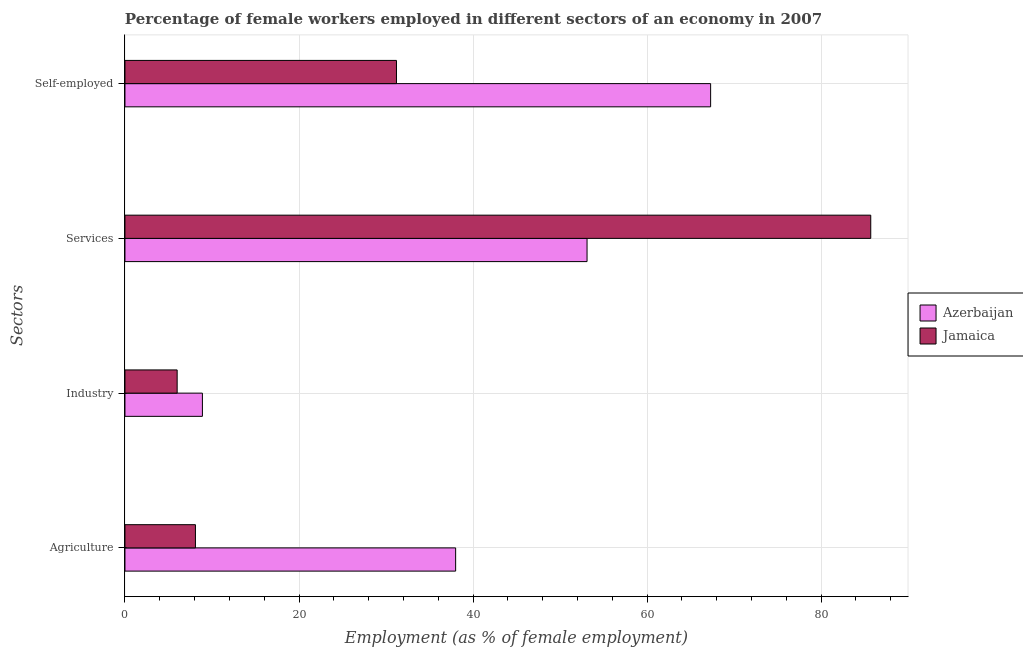How many groups of bars are there?
Make the answer very short. 4. Are the number of bars per tick equal to the number of legend labels?
Offer a terse response. Yes. Are the number of bars on each tick of the Y-axis equal?
Your answer should be very brief. Yes. How many bars are there on the 3rd tick from the top?
Your answer should be very brief. 2. How many bars are there on the 1st tick from the bottom?
Provide a short and direct response. 2. What is the label of the 2nd group of bars from the top?
Provide a succinct answer. Services. What is the percentage of female workers in industry in Azerbaijan?
Provide a short and direct response. 8.9. Across all countries, what is the maximum percentage of self employed female workers?
Offer a terse response. 67.3. Across all countries, what is the minimum percentage of self employed female workers?
Ensure brevity in your answer.  31.2. In which country was the percentage of self employed female workers maximum?
Ensure brevity in your answer.  Azerbaijan. In which country was the percentage of female workers in industry minimum?
Your answer should be very brief. Jamaica. What is the total percentage of female workers in services in the graph?
Give a very brief answer. 138.8. What is the difference between the percentage of female workers in industry in Azerbaijan and that in Jamaica?
Your response must be concise. 2.9. What is the difference between the percentage of self employed female workers in Azerbaijan and the percentage of female workers in services in Jamaica?
Your answer should be very brief. -18.4. What is the average percentage of female workers in services per country?
Offer a very short reply. 69.4. What is the difference between the percentage of female workers in agriculture and percentage of self employed female workers in Jamaica?
Your response must be concise. -23.1. What is the ratio of the percentage of female workers in services in Jamaica to that in Azerbaijan?
Provide a succinct answer. 1.61. What is the difference between the highest and the second highest percentage of female workers in services?
Provide a short and direct response. 32.6. What is the difference between the highest and the lowest percentage of female workers in services?
Your answer should be compact. 32.6. In how many countries, is the percentage of female workers in services greater than the average percentage of female workers in services taken over all countries?
Keep it short and to the point. 1. What does the 1st bar from the top in Agriculture represents?
Ensure brevity in your answer.  Jamaica. What does the 2nd bar from the bottom in Self-employed represents?
Offer a very short reply. Jamaica. Is it the case that in every country, the sum of the percentage of female workers in agriculture and percentage of female workers in industry is greater than the percentage of female workers in services?
Your answer should be compact. No. How many bars are there?
Make the answer very short. 8. Are all the bars in the graph horizontal?
Make the answer very short. Yes. What is the difference between two consecutive major ticks on the X-axis?
Make the answer very short. 20. Are the values on the major ticks of X-axis written in scientific E-notation?
Give a very brief answer. No. Does the graph contain any zero values?
Your answer should be very brief. No. Where does the legend appear in the graph?
Provide a short and direct response. Center right. What is the title of the graph?
Provide a succinct answer. Percentage of female workers employed in different sectors of an economy in 2007. What is the label or title of the X-axis?
Provide a succinct answer. Employment (as % of female employment). What is the label or title of the Y-axis?
Ensure brevity in your answer.  Sectors. What is the Employment (as % of female employment) of Azerbaijan in Agriculture?
Make the answer very short. 38. What is the Employment (as % of female employment) of Jamaica in Agriculture?
Give a very brief answer. 8.1. What is the Employment (as % of female employment) in Azerbaijan in Industry?
Your answer should be very brief. 8.9. What is the Employment (as % of female employment) in Azerbaijan in Services?
Offer a terse response. 53.1. What is the Employment (as % of female employment) of Jamaica in Services?
Your answer should be very brief. 85.7. What is the Employment (as % of female employment) in Azerbaijan in Self-employed?
Keep it short and to the point. 67.3. What is the Employment (as % of female employment) of Jamaica in Self-employed?
Provide a succinct answer. 31.2. Across all Sectors, what is the maximum Employment (as % of female employment) of Azerbaijan?
Your answer should be compact. 67.3. Across all Sectors, what is the maximum Employment (as % of female employment) in Jamaica?
Make the answer very short. 85.7. Across all Sectors, what is the minimum Employment (as % of female employment) in Azerbaijan?
Offer a terse response. 8.9. Across all Sectors, what is the minimum Employment (as % of female employment) of Jamaica?
Keep it short and to the point. 6. What is the total Employment (as % of female employment) of Azerbaijan in the graph?
Provide a succinct answer. 167.3. What is the total Employment (as % of female employment) of Jamaica in the graph?
Ensure brevity in your answer.  131. What is the difference between the Employment (as % of female employment) of Azerbaijan in Agriculture and that in Industry?
Offer a terse response. 29.1. What is the difference between the Employment (as % of female employment) of Jamaica in Agriculture and that in Industry?
Your response must be concise. 2.1. What is the difference between the Employment (as % of female employment) in Azerbaijan in Agriculture and that in Services?
Ensure brevity in your answer.  -15.1. What is the difference between the Employment (as % of female employment) in Jamaica in Agriculture and that in Services?
Give a very brief answer. -77.6. What is the difference between the Employment (as % of female employment) of Azerbaijan in Agriculture and that in Self-employed?
Keep it short and to the point. -29.3. What is the difference between the Employment (as % of female employment) in Jamaica in Agriculture and that in Self-employed?
Offer a terse response. -23.1. What is the difference between the Employment (as % of female employment) in Azerbaijan in Industry and that in Services?
Your answer should be compact. -44.2. What is the difference between the Employment (as % of female employment) in Jamaica in Industry and that in Services?
Keep it short and to the point. -79.7. What is the difference between the Employment (as % of female employment) of Azerbaijan in Industry and that in Self-employed?
Give a very brief answer. -58.4. What is the difference between the Employment (as % of female employment) of Jamaica in Industry and that in Self-employed?
Offer a terse response. -25.2. What is the difference between the Employment (as % of female employment) in Azerbaijan in Services and that in Self-employed?
Your response must be concise. -14.2. What is the difference between the Employment (as % of female employment) in Jamaica in Services and that in Self-employed?
Ensure brevity in your answer.  54.5. What is the difference between the Employment (as % of female employment) in Azerbaijan in Agriculture and the Employment (as % of female employment) in Jamaica in Services?
Your answer should be compact. -47.7. What is the difference between the Employment (as % of female employment) of Azerbaijan in Agriculture and the Employment (as % of female employment) of Jamaica in Self-employed?
Keep it short and to the point. 6.8. What is the difference between the Employment (as % of female employment) of Azerbaijan in Industry and the Employment (as % of female employment) of Jamaica in Services?
Offer a terse response. -76.8. What is the difference between the Employment (as % of female employment) of Azerbaijan in Industry and the Employment (as % of female employment) of Jamaica in Self-employed?
Your answer should be very brief. -22.3. What is the difference between the Employment (as % of female employment) of Azerbaijan in Services and the Employment (as % of female employment) of Jamaica in Self-employed?
Your answer should be very brief. 21.9. What is the average Employment (as % of female employment) of Azerbaijan per Sectors?
Provide a succinct answer. 41.83. What is the average Employment (as % of female employment) of Jamaica per Sectors?
Provide a succinct answer. 32.75. What is the difference between the Employment (as % of female employment) of Azerbaijan and Employment (as % of female employment) of Jamaica in Agriculture?
Provide a short and direct response. 29.9. What is the difference between the Employment (as % of female employment) of Azerbaijan and Employment (as % of female employment) of Jamaica in Services?
Provide a succinct answer. -32.6. What is the difference between the Employment (as % of female employment) in Azerbaijan and Employment (as % of female employment) in Jamaica in Self-employed?
Your response must be concise. 36.1. What is the ratio of the Employment (as % of female employment) in Azerbaijan in Agriculture to that in Industry?
Your response must be concise. 4.27. What is the ratio of the Employment (as % of female employment) in Jamaica in Agriculture to that in Industry?
Make the answer very short. 1.35. What is the ratio of the Employment (as % of female employment) of Azerbaijan in Agriculture to that in Services?
Your response must be concise. 0.72. What is the ratio of the Employment (as % of female employment) of Jamaica in Agriculture to that in Services?
Your answer should be very brief. 0.09. What is the ratio of the Employment (as % of female employment) in Azerbaijan in Agriculture to that in Self-employed?
Your response must be concise. 0.56. What is the ratio of the Employment (as % of female employment) in Jamaica in Agriculture to that in Self-employed?
Give a very brief answer. 0.26. What is the ratio of the Employment (as % of female employment) in Azerbaijan in Industry to that in Services?
Your answer should be compact. 0.17. What is the ratio of the Employment (as % of female employment) in Jamaica in Industry to that in Services?
Your answer should be compact. 0.07. What is the ratio of the Employment (as % of female employment) in Azerbaijan in Industry to that in Self-employed?
Provide a succinct answer. 0.13. What is the ratio of the Employment (as % of female employment) in Jamaica in Industry to that in Self-employed?
Your answer should be compact. 0.19. What is the ratio of the Employment (as % of female employment) in Azerbaijan in Services to that in Self-employed?
Give a very brief answer. 0.79. What is the ratio of the Employment (as % of female employment) of Jamaica in Services to that in Self-employed?
Offer a very short reply. 2.75. What is the difference between the highest and the second highest Employment (as % of female employment) in Jamaica?
Offer a very short reply. 54.5. What is the difference between the highest and the lowest Employment (as % of female employment) of Azerbaijan?
Provide a short and direct response. 58.4. What is the difference between the highest and the lowest Employment (as % of female employment) in Jamaica?
Give a very brief answer. 79.7. 